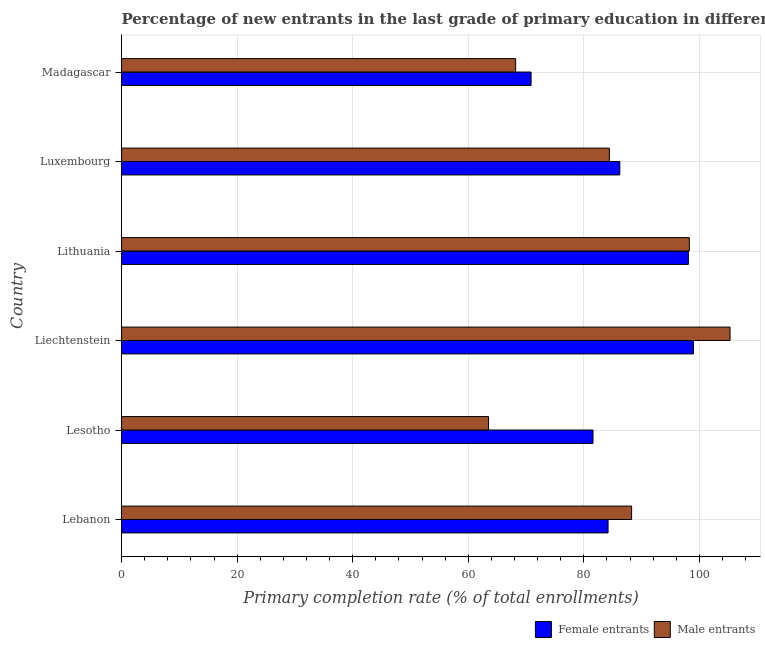How many different coloured bars are there?
Make the answer very short. 2. How many groups of bars are there?
Your response must be concise. 6. Are the number of bars per tick equal to the number of legend labels?
Make the answer very short. Yes. Are the number of bars on each tick of the Y-axis equal?
Offer a terse response. Yes. What is the label of the 5th group of bars from the top?
Your answer should be compact. Lesotho. What is the primary completion rate of male entrants in Madagascar?
Your answer should be compact. 68.2. Across all countries, what is the maximum primary completion rate of male entrants?
Your answer should be very brief. 105.31. Across all countries, what is the minimum primary completion rate of male entrants?
Your answer should be compact. 63.51. In which country was the primary completion rate of male entrants maximum?
Ensure brevity in your answer.  Liechtenstein. In which country was the primary completion rate of female entrants minimum?
Provide a succinct answer. Madagascar. What is the total primary completion rate of female entrants in the graph?
Provide a short and direct response. 519.97. What is the difference between the primary completion rate of female entrants in Liechtenstein and that in Luxembourg?
Offer a very short reply. 12.74. What is the difference between the primary completion rate of male entrants in Liechtenstein and the primary completion rate of female entrants in Madagascar?
Make the answer very short. 34.44. What is the average primary completion rate of male entrants per country?
Provide a succinct answer. 84.67. What is the difference between the primary completion rate of female entrants and primary completion rate of male entrants in Luxembourg?
Ensure brevity in your answer.  1.81. In how many countries, is the primary completion rate of male entrants greater than 12 %?
Make the answer very short. 6. What is the ratio of the primary completion rate of male entrants in Lesotho to that in Luxembourg?
Make the answer very short. 0.75. What is the difference between the highest and the second highest primary completion rate of female entrants?
Ensure brevity in your answer.  0.88. What is the difference between the highest and the lowest primary completion rate of male entrants?
Your answer should be very brief. 41.8. Is the sum of the primary completion rate of male entrants in Lebanon and Madagascar greater than the maximum primary completion rate of female entrants across all countries?
Offer a very short reply. Yes. What does the 1st bar from the top in Madagascar represents?
Make the answer very short. Male entrants. What does the 2nd bar from the bottom in Lithuania represents?
Offer a very short reply. Male entrants. Are all the bars in the graph horizontal?
Keep it short and to the point. Yes. What is the difference between two consecutive major ticks on the X-axis?
Your answer should be compact. 20. Does the graph contain any zero values?
Make the answer very short. No. What is the title of the graph?
Your answer should be very brief. Percentage of new entrants in the last grade of primary education in different countries. Does "Net National savings" appear as one of the legend labels in the graph?
Make the answer very short. No. What is the label or title of the X-axis?
Provide a short and direct response. Primary completion rate (% of total enrollments). What is the label or title of the Y-axis?
Give a very brief answer. Country. What is the Primary completion rate (% of total enrollments) of Female entrants in Lebanon?
Ensure brevity in your answer.  84.2. What is the Primary completion rate (% of total enrollments) of Male entrants in Lebanon?
Offer a terse response. 88.27. What is the Primary completion rate (% of total enrollments) in Female entrants in Lesotho?
Offer a terse response. 81.59. What is the Primary completion rate (% of total enrollments) of Male entrants in Lesotho?
Your answer should be compact. 63.51. What is the Primary completion rate (% of total enrollments) in Female entrants in Liechtenstein?
Give a very brief answer. 98.97. What is the Primary completion rate (% of total enrollments) in Male entrants in Liechtenstein?
Your answer should be very brief. 105.31. What is the Primary completion rate (% of total enrollments) of Female entrants in Lithuania?
Offer a terse response. 98.1. What is the Primary completion rate (% of total enrollments) of Male entrants in Lithuania?
Your answer should be compact. 98.26. What is the Primary completion rate (% of total enrollments) in Female entrants in Luxembourg?
Provide a succinct answer. 86.23. What is the Primary completion rate (% of total enrollments) in Male entrants in Luxembourg?
Give a very brief answer. 84.42. What is the Primary completion rate (% of total enrollments) of Female entrants in Madagascar?
Your response must be concise. 70.87. What is the Primary completion rate (% of total enrollments) in Male entrants in Madagascar?
Your answer should be very brief. 68.2. Across all countries, what is the maximum Primary completion rate (% of total enrollments) of Female entrants?
Offer a very short reply. 98.97. Across all countries, what is the maximum Primary completion rate (% of total enrollments) in Male entrants?
Your answer should be compact. 105.31. Across all countries, what is the minimum Primary completion rate (% of total enrollments) in Female entrants?
Offer a very short reply. 70.87. Across all countries, what is the minimum Primary completion rate (% of total enrollments) of Male entrants?
Make the answer very short. 63.51. What is the total Primary completion rate (% of total enrollments) in Female entrants in the graph?
Keep it short and to the point. 519.97. What is the total Primary completion rate (% of total enrollments) of Male entrants in the graph?
Make the answer very short. 507.99. What is the difference between the Primary completion rate (% of total enrollments) of Female entrants in Lebanon and that in Lesotho?
Make the answer very short. 2.61. What is the difference between the Primary completion rate (% of total enrollments) in Male entrants in Lebanon and that in Lesotho?
Make the answer very short. 24.76. What is the difference between the Primary completion rate (% of total enrollments) of Female entrants in Lebanon and that in Liechtenstein?
Offer a very short reply. -14.78. What is the difference between the Primary completion rate (% of total enrollments) of Male entrants in Lebanon and that in Liechtenstein?
Provide a short and direct response. -17.04. What is the difference between the Primary completion rate (% of total enrollments) of Female entrants in Lebanon and that in Lithuania?
Provide a short and direct response. -13.9. What is the difference between the Primary completion rate (% of total enrollments) of Male entrants in Lebanon and that in Lithuania?
Provide a succinct answer. -9.99. What is the difference between the Primary completion rate (% of total enrollments) of Female entrants in Lebanon and that in Luxembourg?
Your answer should be very brief. -2.03. What is the difference between the Primary completion rate (% of total enrollments) of Male entrants in Lebanon and that in Luxembourg?
Give a very brief answer. 3.85. What is the difference between the Primary completion rate (% of total enrollments) in Female entrants in Lebanon and that in Madagascar?
Give a very brief answer. 13.32. What is the difference between the Primary completion rate (% of total enrollments) of Male entrants in Lebanon and that in Madagascar?
Provide a short and direct response. 20.07. What is the difference between the Primary completion rate (% of total enrollments) in Female entrants in Lesotho and that in Liechtenstein?
Ensure brevity in your answer.  -17.38. What is the difference between the Primary completion rate (% of total enrollments) in Male entrants in Lesotho and that in Liechtenstein?
Keep it short and to the point. -41.8. What is the difference between the Primary completion rate (% of total enrollments) of Female entrants in Lesotho and that in Lithuania?
Your response must be concise. -16.51. What is the difference between the Primary completion rate (% of total enrollments) in Male entrants in Lesotho and that in Lithuania?
Ensure brevity in your answer.  -34.75. What is the difference between the Primary completion rate (% of total enrollments) of Female entrants in Lesotho and that in Luxembourg?
Offer a very short reply. -4.64. What is the difference between the Primary completion rate (% of total enrollments) in Male entrants in Lesotho and that in Luxembourg?
Provide a succinct answer. -20.91. What is the difference between the Primary completion rate (% of total enrollments) of Female entrants in Lesotho and that in Madagascar?
Provide a short and direct response. 10.72. What is the difference between the Primary completion rate (% of total enrollments) of Male entrants in Lesotho and that in Madagascar?
Provide a short and direct response. -4.69. What is the difference between the Primary completion rate (% of total enrollments) of Female entrants in Liechtenstein and that in Lithuania?
Your response must be concise. 0.88. What is the difference between the Primary completion rate (% of total enrollments) in Male entrants in Liechtenstein and that in Lithuania?
Give a very brief answer. 7.05. What is the difference between the Primary completion rate (% of total enrollments) in Female entrants in Liechtenstein and that in Luxembourg?
Provide a succinct answer. 12.74. What is the difference between the Primary completion rate (% of total enrollments) in Male entrants in Liechtenstein and that in Luxembourg?
Make the answer very short. 20.89. What is the difference between the Primary completion rate (% of total enrollments) of Female entrants in Liechtenstein and that in Madagascar?
Offer a terse response. 28.1. What is the difference between the Primary completion rate (% of total enrollments) of Male entrants in Liechtenstein and that in Madagascar?
Give a very brief answer. 37.11. What is the difference between the Primary completion rate (% of total enrollments) in Female entrants in Lithuania and that in Luxembourg?
Your response must be concise. 11.87. What is the difference between the Primary completion rate (% of total enrollments) in Male entrants in Lithuania and that in Luxembourg?
Your response must be concise. 13.84. What is the difference between the Primary completion rate (% of total enrollments) in Female entrants in Lithuania and that in Madagascar?
Provide a short and direct response. 27.22. What is the difference between the Primary completion rate (% of total enrollments) in Male entrants in Lithuania and that in Madagascar?
Ensure brevity in your answer.  30.06. What is the difference between the Primary completion rate (% of total enrollments) of Female entrants in Luxembourg and that in Madagascar?
Make the answer very short. 15.36. What is the difference between the Primary completion rate (% of total enrollments) of Male entrants in Luxembourg and that in Madagascar?
Your answer should be compact. 16.22. What is the difference between the Primary completion rate (% of total enrollments) in Female entrants in Lebanon and the Primary completion rate (% of total enrollments) in Male entrants in Lesotho?
Offer a terse response. 20.69. What is the difference between the Primary completion rate (% of total enrollments) in Female entrants in Lebanon and the Primary completion rate (% of total enrollments) in Male entrants in Liechtenstein?
Make the answer very short. -21.12. What is the difference between the Primary completion rate (% of total enrollments) of Female entrants in Lebanon and the Primary completion rate (% of total enrollments) of Male entrants in Lithuania?
Offer a terse response. -14.07. What is the difference between the Primary completion rate (% of total enrollments) in Female entrants in Lebanon and the Primary completion rate (% of total enrollments) in Male entrants in Luxembourg?
Provide a short and direct response. -0.23. What is the difference between the Primary completion rate (% of total enrollments) in Female entrants in Lebanon and the Primary completion rate (% of total enrollments) in Male entrants in Madagascar?
Provide a succinct answer. 16. What is the difference between the Primary completion rate (% of total enrollments) of Female entrants in Lesotho and the Primary completion rate (% of total enrollments) of Male entrants in Liechtenstein?
Provide a short and direct response. -23.72. What is the difference between the Primary completion rate (% of total enrollments) of Female entrants in Lesotho and the Primary completion rate (% of total enrollments) of Male entrants in Lithuania?
Your response must be concise. -16.67. What is the difference between the Primary completion rate (% of total enrollments) in Female entrants in Lesotho and the Primary completion rate (% of total enrollments) in Male entrants in Luxembourg?
Offer a very short reply. -2.83. What is the difference between the Primary completion rate (% of total enrollments) in Female entrants in Lesotho and the Primary completion rate (% of total enrollments) in Male entrants in Madagascar?
Offer a very short reply. 13.39. What is the difference between the Primary completion rate (% of total enrollments) of Female entrants in Liechtenstein and the Primary completion rate (% of total enrollments) of Male entrants in Lithuania?
Offer a very short reply. 0.71. What is the difference between the Primary completion rate (% of total enrollments) in Female entrants in Liechtenstein and the Primary completion rate (% of total enrollments) in Male entrants in Luxembourg?
Keep it short and to the point. 14.55. What is the difference between the Primary completion rate (% of total enrollments) in Female entrants in Liechtenstein and the Primary completion rate (% of total enrollments) in Male entrants in Madagascar?
Ensure brevity in your answer.  30.77. What is the difference between the Primary completion rate (% of total enrollments) of Female entrants in Lithuania and the Primary completion rate (% of total enrollments) of Male entrants in Luxembourg?
Give a very brief answer. 13.67. What is the difference between the Primary completion rate (% of total enrollments) of Female entrants in Lithuania and the Primary completion rate (% of total enrollments) of Male entrants in Madagascar?
Provide a succinct answer. 29.9. What is the difference between the Primary completion rate (% of total enrollments) of Female entrants in Luxembourg and the Primary completion rate (% of total enrollments) of Male entrants in Madagascar?
Provide a succinct answer. 18.03. What is the average Primary completion rate (% of total enrollments) of Female entrants per country?
Keep it short and to the point. 86.66. What is the average Primary completion rate (% of total enrollments) in Male entrants per country?
Your response must be concise. 84.66. What is the difference between the Primary completion rate (% of total enrollments) in Female entrants and Primary completion rate (% of total enrollments) in Male entrants in Lebanon?
Your answer should be very brief. -4.08. What is the difference between the Primary completion rate (% of total enrollments) of Female entrants and Primary completion rate (% of total enrollments) of Male entrants in Lesotho?
Provide a short and direct response. 18.08. What is the difference between the Primary completion rate (% of total enrollments) in Female entrants and Primary completion rate (% of total enrollments) in Male entrants in Liechtenstein?
Offer a terse response. -6.34. What is the difference between the Primary completion rate (% of total enrollments) of Female entrants and Primary completion rate (% of total enrollments) of Male entrants in Lithuania?
Offer a very short reply. -0.16. What is the difference between the Primary completion rate (% of total enrollments) in Female entrants and Primary completion rate (% of total enrollments) in Male entrants in Luxembourg?
Keep it short and to the point. 1.81. What is the difference between the Primary completion rate (% of total enrollments) of Female entrants and Primary completion rate (% of total enrollments) of Male entrants in Madagascar?
Give a very brief answer. 2.67. What is the ratio of the Primary completion rate (% of total enrollments) of Female entrants in Lebanon to that in Lesotho?
Your response must be concise. 1.03. What is the ratio of the Primary completion rate (% of total enrollments) in Male entrants in Lebanon to that in Lesotho?
Your response must be concise. 1.39. What is the ratio of the Primary completion rate (% of total enrollments) of Female entrants in Lebanon to that in Liechtenstein?
Offer a very short reply. 0.85. What is the ratio of the Primary completion rate (% of total enrollments) in Male entrants in Lebanon to that in Liechtenstein?
Provide a succinct answer. 0.84. What is the ratio of the Primary completion rate (% of total enrollments) of Female entrants in Lebanon to that in Lithuania?
Your response must be concise. 0.86. What is the ratio of the Primary completion rate (% of total enrollments) of Male entrants in Lebanon to that in Lithuania?
Provide a short and direct response. 0.9. What is the ratio of the Primary completion rate (% of total enrollments) of Female entrants in Lebanon to that in Luxembourg?
Give a very brief answer. 0.98. What is the ratio of the Primary completion rate (% of total enrollments) of Male entrants in Lebanon to that in Luxembourg?
Make the answer very short. 1.05. What is the ratio of the Primary completion rate (% of total enrollments) of Female entrants in Lebanon to that in Madagascar?
Offer a terse response. 1.19. What is the ratio of the Primary completion rate (% of total enrollments) of Male entrants in Lebanon to that in Madagascar?
Offer a very short reply. 1.29. What is the ratio of the Primary completion rate (% of total enrollments) in Female entrants in Lesotho to that in Liechtenstein?
Provide a succinct answer. 0.82. What is the ratio of the Primary completion rate (% of total enrollments) of Male entrants in Lesotho to that in Liechtenstein?
Your response must be concise. 0.6. What is the ratio of the Primary completion rate (% of total enrollments) in Female entrants in Lesotho to that in Lithuania?
Your answer should be compact. 0.83. What is the ratio of the Primary completion rate (% of total enrollments) of Male entrants in Lesotho to that in Lithuania?
Offer a terse response. 0.65. What is the ratio of the Primary completion rate (% of total enrollments) of Female entrants in Lesotho to that in Luxembourg?
Make the answer very short. 0.95. What is the ratio of the Primary completion rate (% of total enrollments) in Male entrants in Lesotho to that in Luxembourg?
Give a very brief answer. 0.75. What is the ratio of the Primary completion rate (% of total enrollments) of Female entrants in Lesotho to that in Madagascar?
Provide a succinct answer. 1.15. What is the ratio of the Primary completion rate (% of total enrollments) in Male entrants in Lesotho to that in Madagascar?
Give a very brief answer. 0.93. What is the ratio of the Primary completion rate (% of total enrollments) of Female entrants in Liechtenstein to that in Lithuania?
Offer a very short reply. 1.01. What is the ratio of the Primary completion rate (% of total enrollments) of Male entrants in Liechtenstein to that in Lithuania?
Provide a short and direct response. 1.07. What is the ratio of the Primary completion rate (% of total enrollments) in Female entrants in Liechtenstein to that in Luxembourg?
Ensure brevity in your answer.  1.15. What is the ratio of the Primary completion rate (% of total enrollments) in Male entrants in Liechtenstein to that in Luxembourg?
Make the answer very short. 1.25. What is the ratio of the Primary completion rate (% of total enrollments) of Female entrants in Liechtenstein to that in Madagascar?
Provide a short and direct response. 1.4. What is the ratio of the Primary completion rate (% of total enrollments) in Male entrants in Liechtenstein to that in Madagascar?
Ensure brevity in your answer.  1.54. What is the ratio of the Primary completion rate (% of total enrollments) of Female entrants in Lithuania to that in Luxembourg?
Make the answer very short. 1.14. What is the ratio of the Primary completion rate (% of total enrollments) of Male entrants in Lithuania to that in Luxembourg?
Provide a short and direct response. 1.16. What is the ratio of the Primary completion rate (% of total enrollments) of Female entrants in Lithuania to that in Madagascar?
Offer a very short reply. 1.38. What is the ratio of the Primary completion rate (% of total enrollments) of Male entrants in Lithuania to that in Madagascar?
Your answer should be very brief. 1.44. What is the ratio of the Primary completion rate (% of total enrollments) in Female entrants in Luxembourg to that in Madagascar?
Your answer should be very brief. 1.22. What is the ratio of the Primary completion rate (% of total enrollments) in Male entrants in Luxembourg to that in Madagascar?
Your answer should be very brief. 1.24. What is the difference between the highest and the second highest Primary completion rate (% of total enrollments) of Female entrants?
Your answer should be very brief. 0.88. What is the difference between the highest and the second highest Primary completion rate (% of total enrollments) in Male entrants?
Ensure brevity in your answer.  7.05. What is the difference between the highest and the lowest Primary completion rate (% of total enrollments) of Female entrants?
Give a very brief answer. 28.1. What is the difference between the highest and the lowest Primary completion rate (% of total enrollments) of Male entrants?
Make the answer very short. 41.8. 